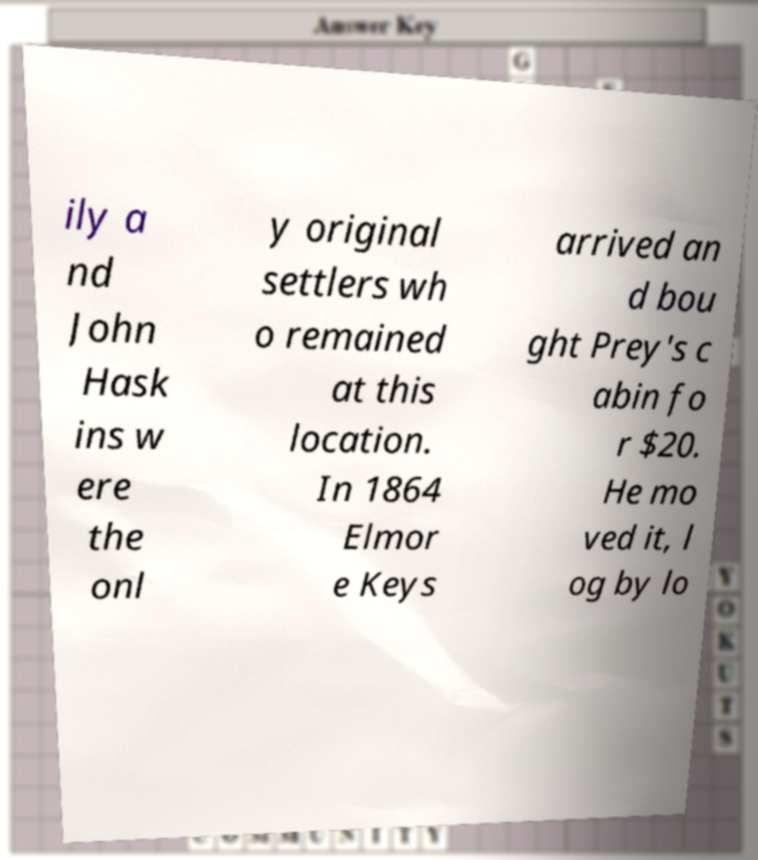Please identify and transcribe the text found in this image. ily a nd John Hask ins w ere the onl y original settlers wh o remained at this location. In 1864 Elmor e Keys arrived an d bou ght Prey's c abin fo r $20. He mo ved it, l og by lo 